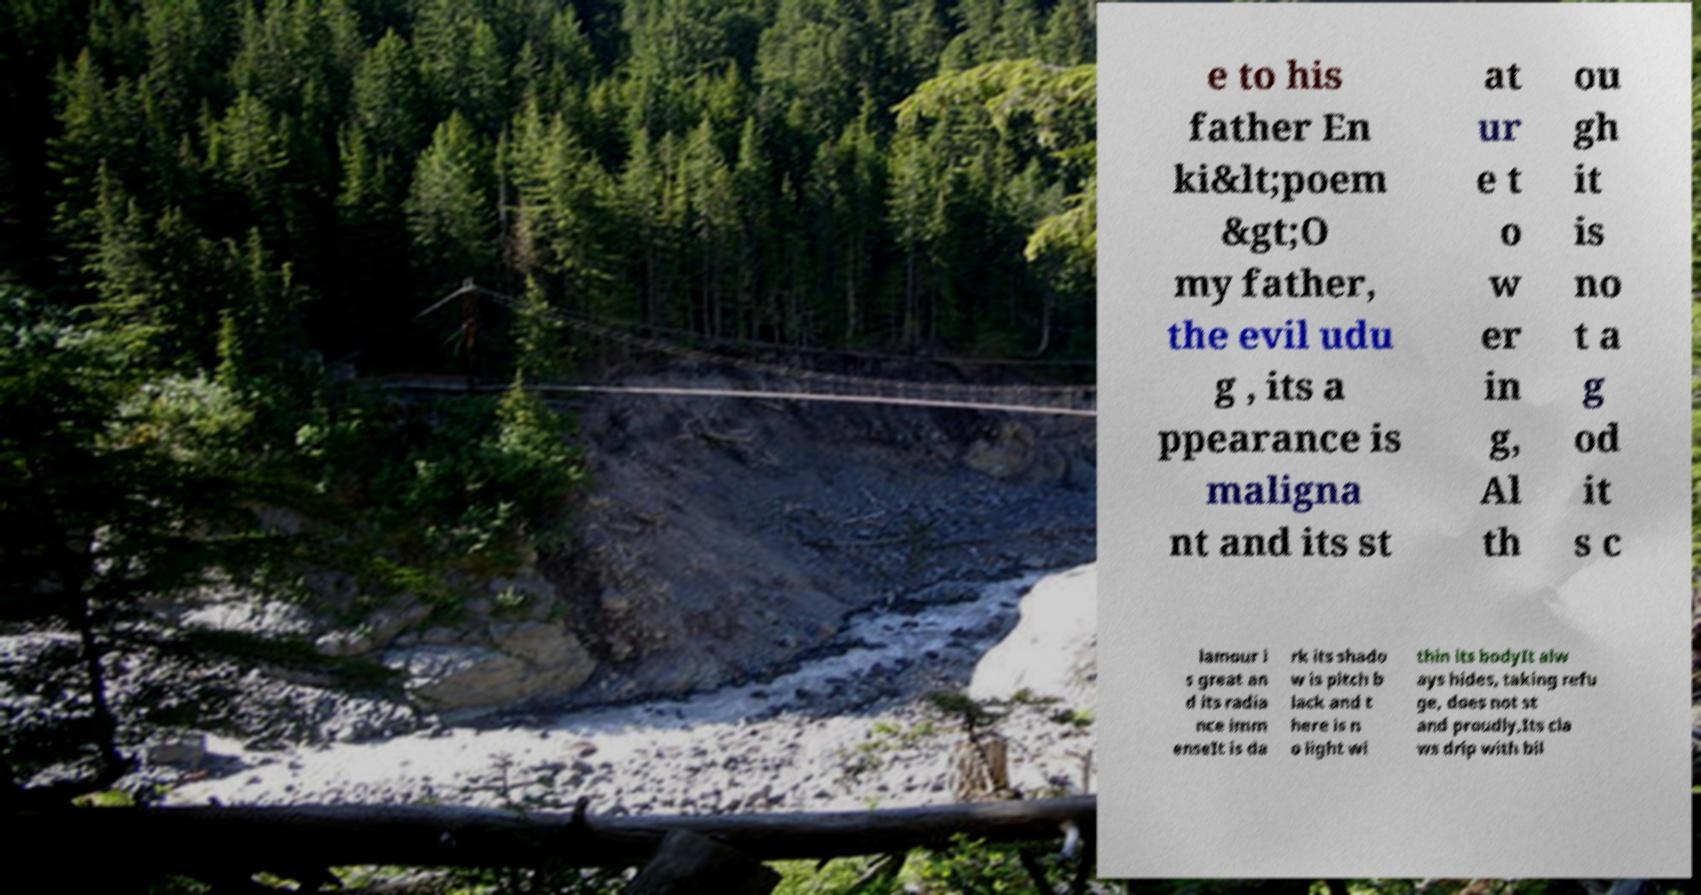For documentation purposes, I need the text within this image transcribed. Could you provide that? e to his father En ki&lt;poem &gt;O my father, the evil udu g , its a ppearance is maligna nt and its st at ur e t o w er in g, Al th ou gh it is no t a g od it s c lamour i s great an d its radia nce imm enseIt is da rk its shado w is pitch b lack and t here is n o light wi thin its bodyIt alw ays hides, taking refu ge, does not st and proudly,Its cla ws drip with bil 